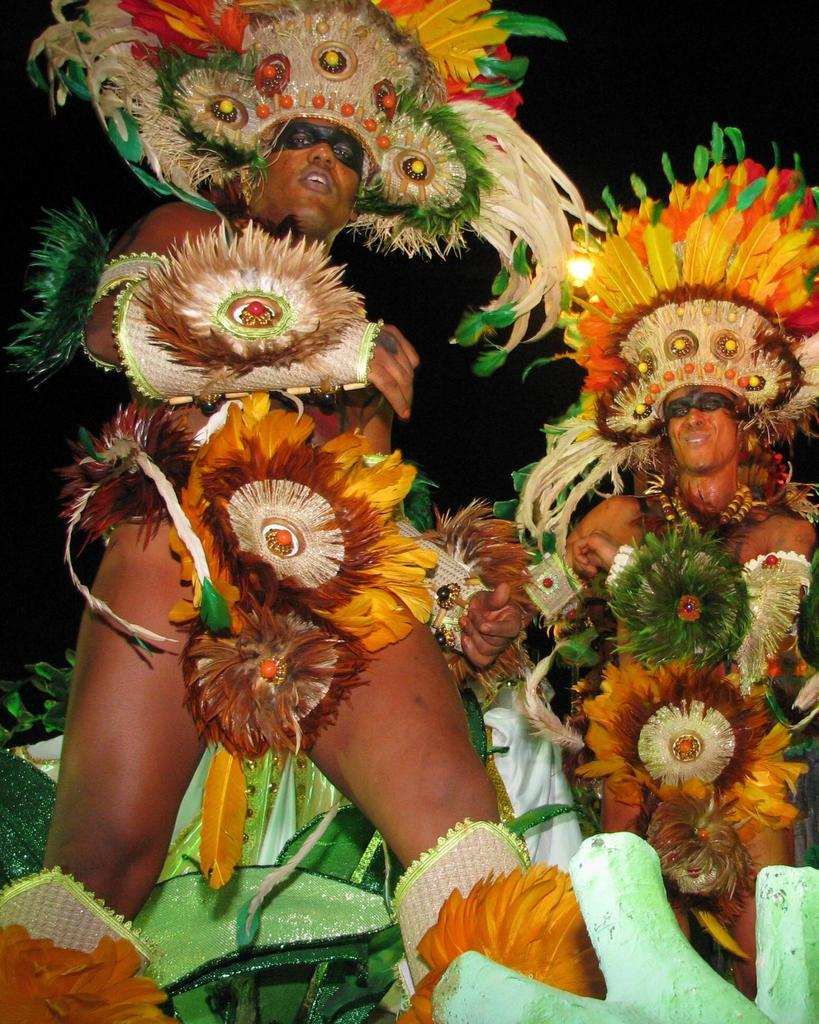How many people are in the image? There are two people in the image. Where are the two people located in the image? The two people are on the right and left side of the image. What are the two people wearing? Both people are wearing costumes. What type of humor can be seen in the image? There is no humor present in the image; it simply shows two people wearing costumes. Is there a jail visible in the image? There is no jail present in the image. 